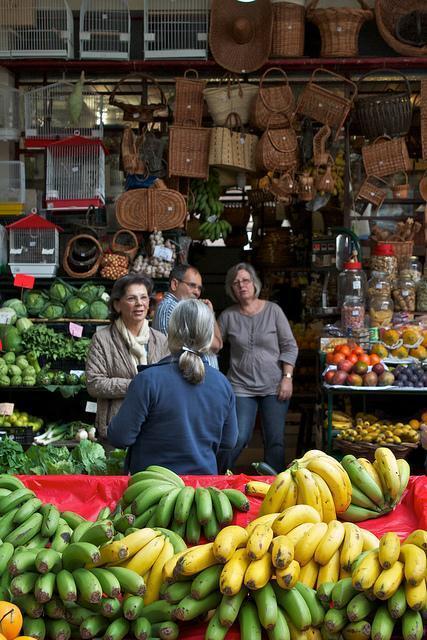How many bananas are there?
Give a very brief answer. 8. How many people are visible?
Give a very brief answer. 3. 